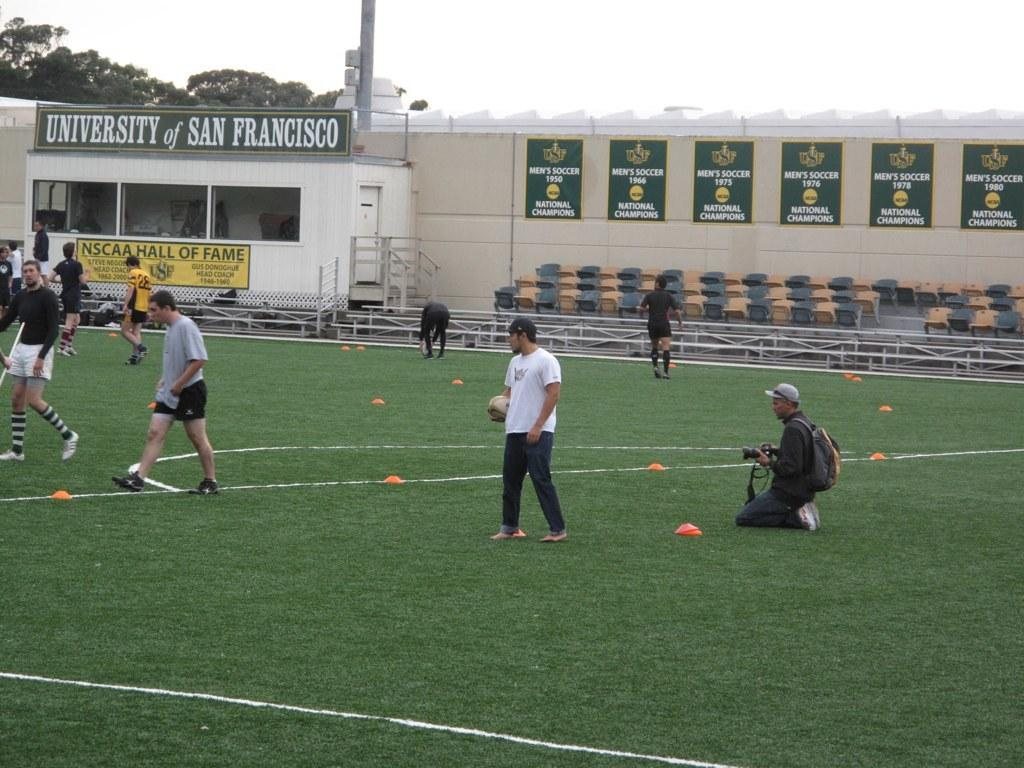<image>
Relay a brief, clear account of the picture shown. Players stand on a field at the University of San Francisco 